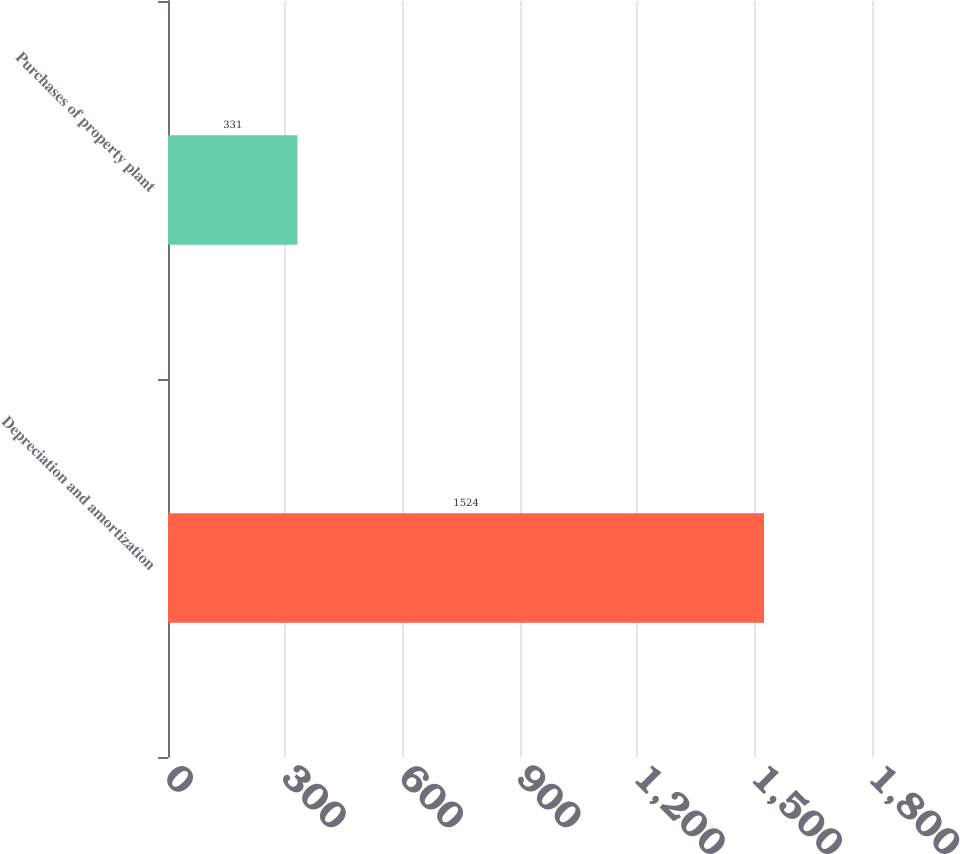<chart> <loc_0><loc_0><loc_500><loc_500><bar_chart><fcel>Depreciation and amortization<fcel>Purchases of property plant<nl><fcel>1524<fcel>331<nl></chart> 